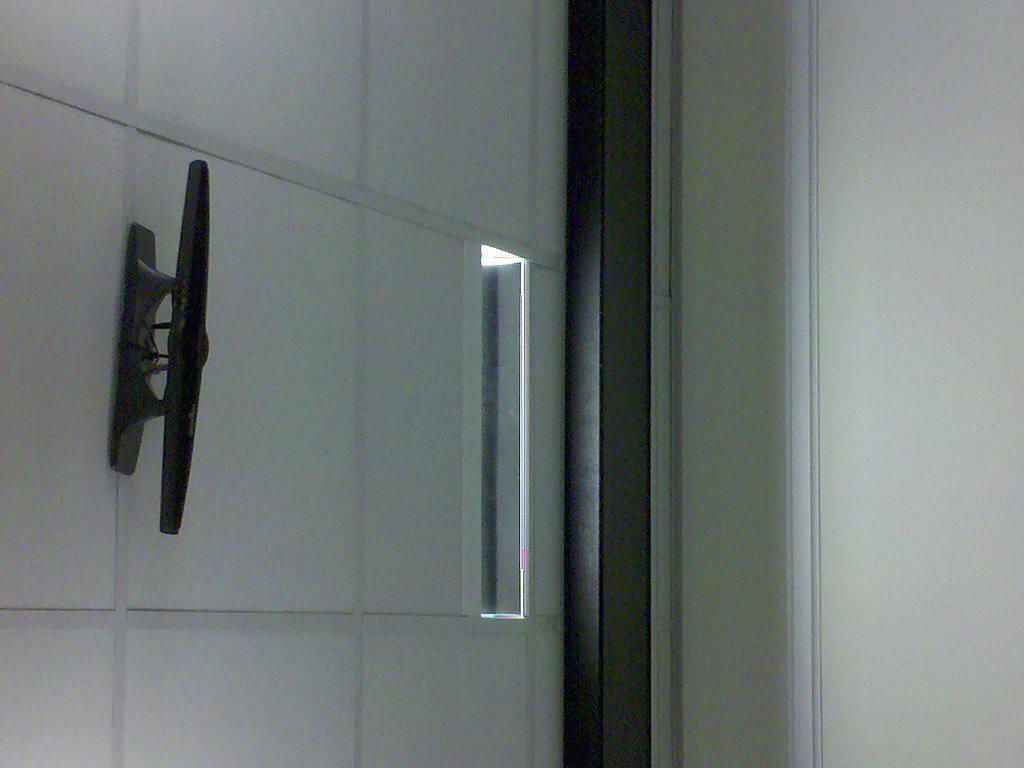In one or two sentences, can you explain what this image depicts? This image is clicked inside the building. On the left, we can see a gate on which there is a handle made up of metal. On the right, there is a wall. 